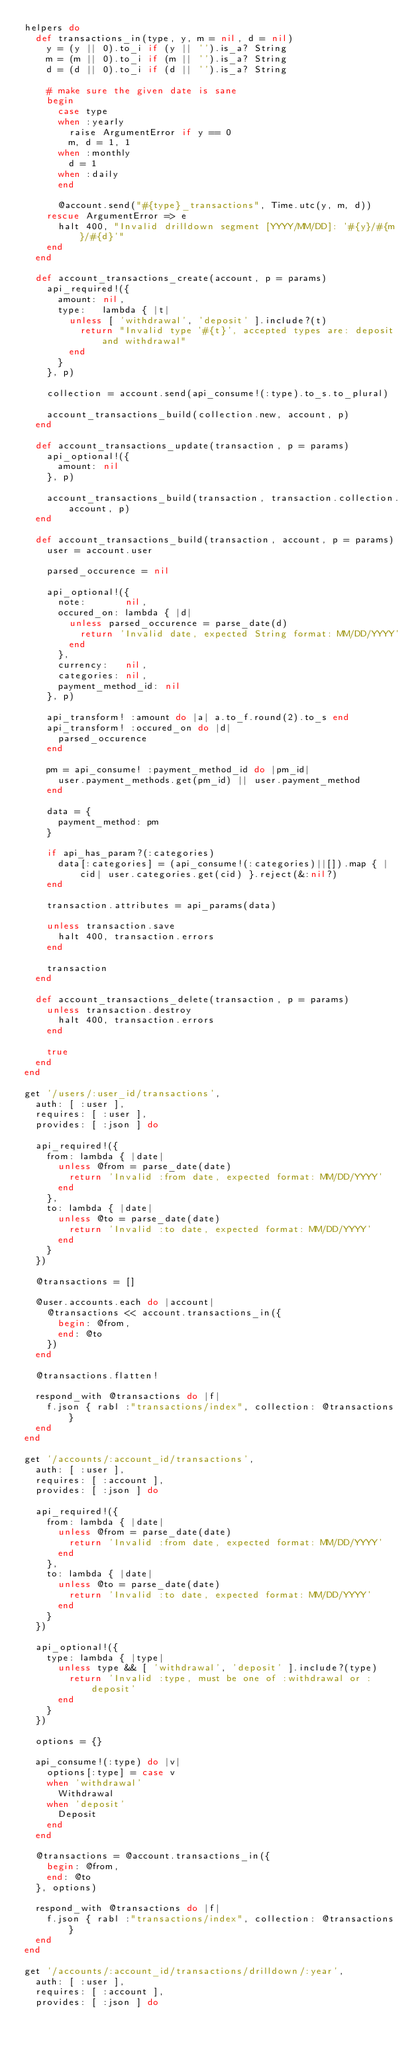<code> <loc_0><loc_0><loc_500><loc_500><_Ruby_>helpers do
  def transactions_in(type, y, m = nil, d = nil)
    y = (y || 0).to_i if (y || '').is_a? String
    m = (m || 0).to_i if (m || '').is_a? String
    d = (d || 0).to_i if (d || '').is_a? String

    # make sure the given date is sane
    begin
      case type
      when :yearly
        raise ArgumentError if y == 0
        m, d = 1, 1
      when :monthly
        d = 1
      when :daily
      end

      @account.send("#{type}_transactions", Time.utc(y, m, d))
    rescue ArgumentError => e
      halt 400, "Invalid drilldown segment [YYYY/MM/DD]: '#{y}/#{m}/#{d}'"
    end
  end

  def account_transactions_create(account, p = params)
    api_required!({
      amount: nil,
      type:   lambda { |t|
        unless [ 'withdrawal', 'deposit' ].include?(t)
          return "Invalid type '#{t}', accepted types are: deposit and withdrawal"
        end
      }
    }, p)

    collection = account.send(api_consume!(:type).to_s.to_plural)

    account_transactions_build(collection.new, account, p)
  end

  def account_transactions_update(transaction, p = params)
    api_optional!({
      amount: nil
    }, p)

    account_transactions_build(transaction, transaction.collection.account, p)
  end

  def account_transactions_build(transaction, account, p = params)
    user = account.user

    parsed_occurence = nil

    api_optional!({
      note:       nil,
      occured_on: lambda { |d|
        unless parsed_occurence = parse_date(d)
          return 'Invalid date, expected String format: MM/DD/YYYY'
        end
      },
      currency:   nil,
      categories: nil,
      payment_method_id: nil
    }, p)

    api_transform! :amount do |a| a.to_f.round(2).to_s end
    api_transform! :occured_on do |d|
      parsed_occurence
    end

    pm = api_consume! :payment_method_id do |pm_id|
      user.payment_methods.get(pm_id) || user.payment_method
    end

    data = {
      payment_method: pm
    }

    if api_has_param?(:categories)
      data[:categories] = (api_consume!(:categories)||[]).map { |cid| user.categories.get(cid) }.reject(&:nil?)
    end

    transaction.attributes = api_params(data)

    unless transaction.save
      halt 400, transaction.errors
    end

    transaction
  end

  def account_transactions_delete(transaction, p = params)
    unless transaction.destroy
      halt 400, transaction.errors
    end

    true
  end
end

get '/users/:user_id/transactions',
  auth: [ :user ],
  requires: [ :user ],
  provides: [ :json ] do

  api_required!({
    from: lambda { |date|
      unless @from = parse_date(date)
        return 'Invalid :from date, expected format: MM/DD/YYYY'
      end
    },
    to: lambda { |date|
      unless @to = parse_date(date)
        return 'Invalid :to date, expected format: MM/DD/YYYY'
      end
    }
  })

  @transactions = []

  @user.accounts.each do |account|
    @transactions << account.transactions_in({
      begin: @from,
      end: @to
    })
  end

  @transactions.flatten!

  respond_with @transactions do |f|
    f.json { rabl :"transactions/index", collection: @transactions }
  end
end

get '/accounts/:account_id/transactions',
  auth: [ :user ],
  requires: [ :account ],
  provides: [ :json ] do

  api_required!({
    from: lambda { |date|
      unless @from = parse_date(date)
        return 'Invalid :from date, expected format: MM/DD/YYYY'
      end
    },
    to: lambda { |date|
      unless @to = parse_date(date)
        return 'Invalid :to date, expected format: MM/DD/YYYY'
      end
    }
  })

  api_optional!({
    type: lambda { |type|
      unless type && [ 'withdrawal', 'deposit' ].include?(type)
        return 'Invalid :type, must be one of :withdrawal or :deposit'
      end
    }
  })

  options = {}

  api_consume!(:type) do |v|
    options[:type] = case v
    when 'withdrawal'
      Withdrawal
    when 'deposit'
      Deposit
    end
  end

  @transactions = @account.transactions_in({
    begin: @from,
    end: @to
  }, options)

  respond_with @transactions do |f|
    f.json { rabl :"transactions/index", collection: @transactions }
  end
end

get '/accounts/:account_id/transactions/drilldown/:year',
  auth: [ :user ],
  requires: [ :account ],
  provides: [ :json ] do
</code> 